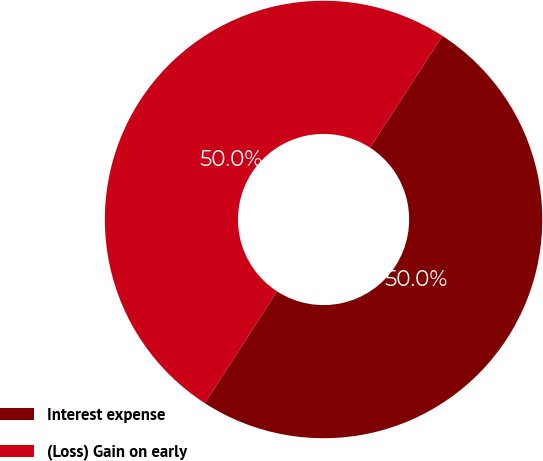Convert chart. <chart><loc_0><loc_0><loc_500><loc_500><pie_chart><fcel>Interest expense<fcel>(Loss) Gain on early<nl><fcel>50.0%<fcel>50.0%<nl></chart> 